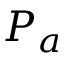Convert formula to latex. <formula><loc_0><loc_0><loc_500><loc_500>P _ { a }</formula> 